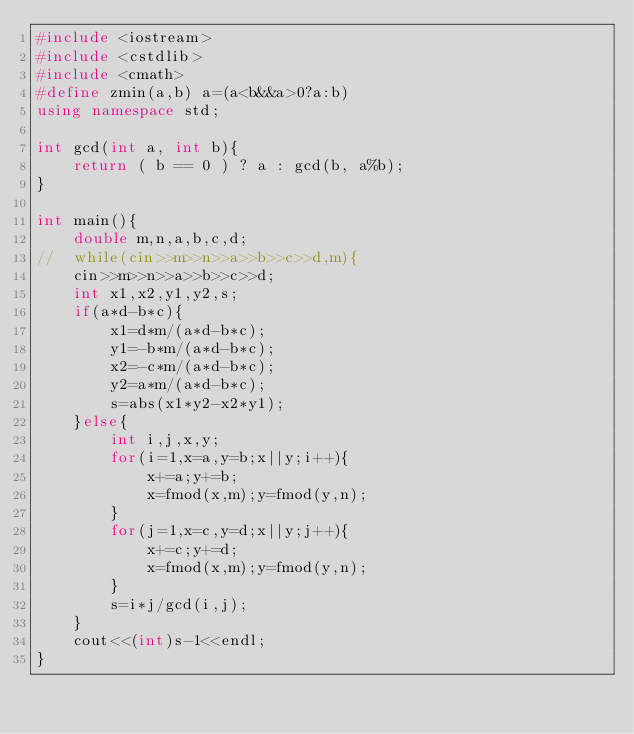<code> <loc_0><loc_0><loc_500><loc_500><_C++_>#include <iostream>
#include <cstdlib>
#include <cmath>
#define zmin(a,b) a=(a<b&&a>0?a:b)
using namespace std;

int gcd(int a, int b){
	return ( b == 0 ) ? a : gcd(b, a%b);
}

int main(){
	double m,n,a,b,c,d;
//	while(cin>>m>>n>>a>>b>>c>>d,m){
	cin>>m>>n>>a>>b>>c>>d;
	int x1,x2,y1,y2,s;
	if(a*d-b*c){
		x1=d*m/(a*d-b*c);
		y1=-b*m/(a*d-b*c);
		x2=-c*m/(a*d-b*c);
		y2=a*m/(a*d-b*c);
		s=abs(x1*y2-x2*y1);
	}else{
		int i,j,x,y;
		for(i=1,x=a,y=b;x||y;i++){
			x+=a;y+=b;
			x=fmod(x,m);y=fmod(y,n);
		}
		for(j=1,x=c,y=d;x||y;j++){
			x+=c;y+=d;
			x=fmod(x,m);y=fmod(y,n);
		}
		s=i*j/gcd(i,j);
	}
	cout<<(int)s-1<<endl;
}</code> 